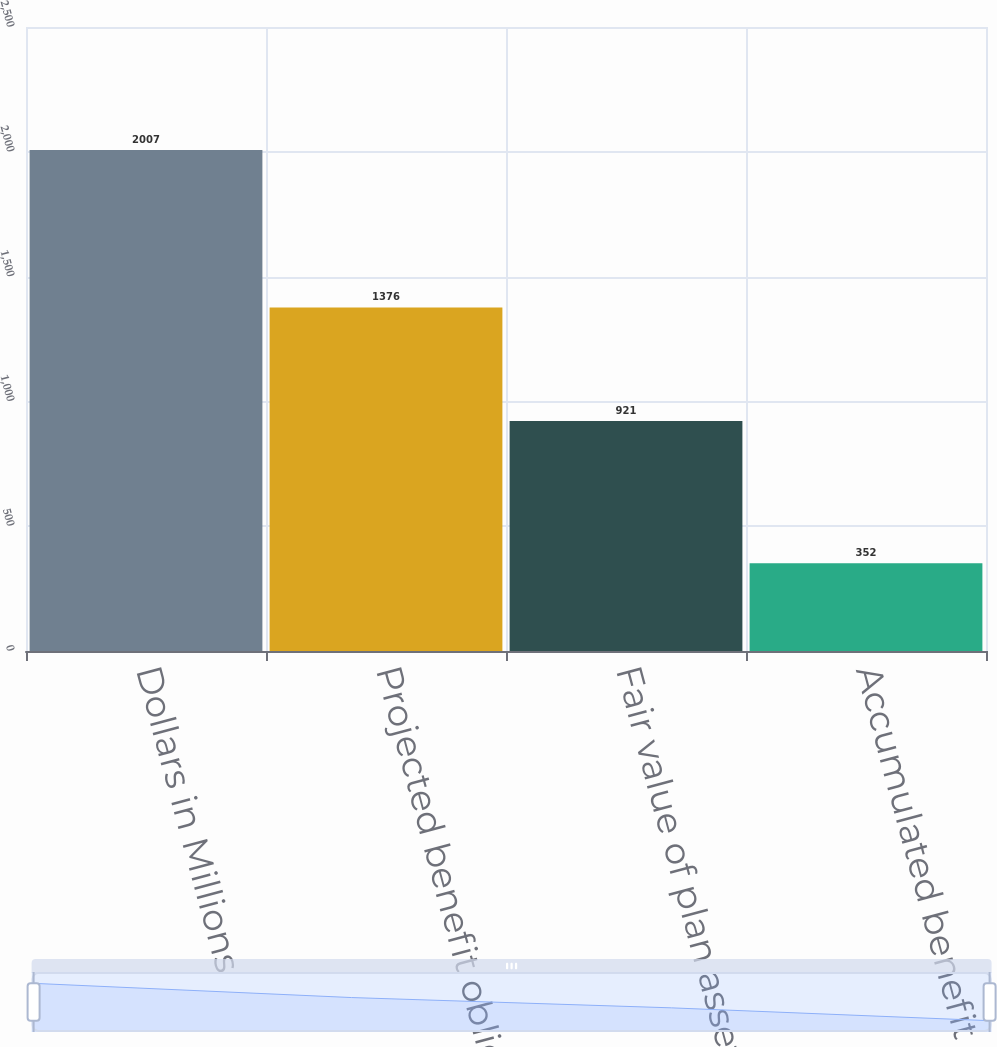Convert chart. <chart><loc_0><loc_0><loc_500><loc_500><bar_chart><fcel>Dollars in Millions<fcel>Projected benefit obligation<fcel>Fair value of plan assets<fcel>Accumulated benefit obligation<nl><fcel>2007<fcel>1376<fcel>921<fcel>352<nl></chart> 